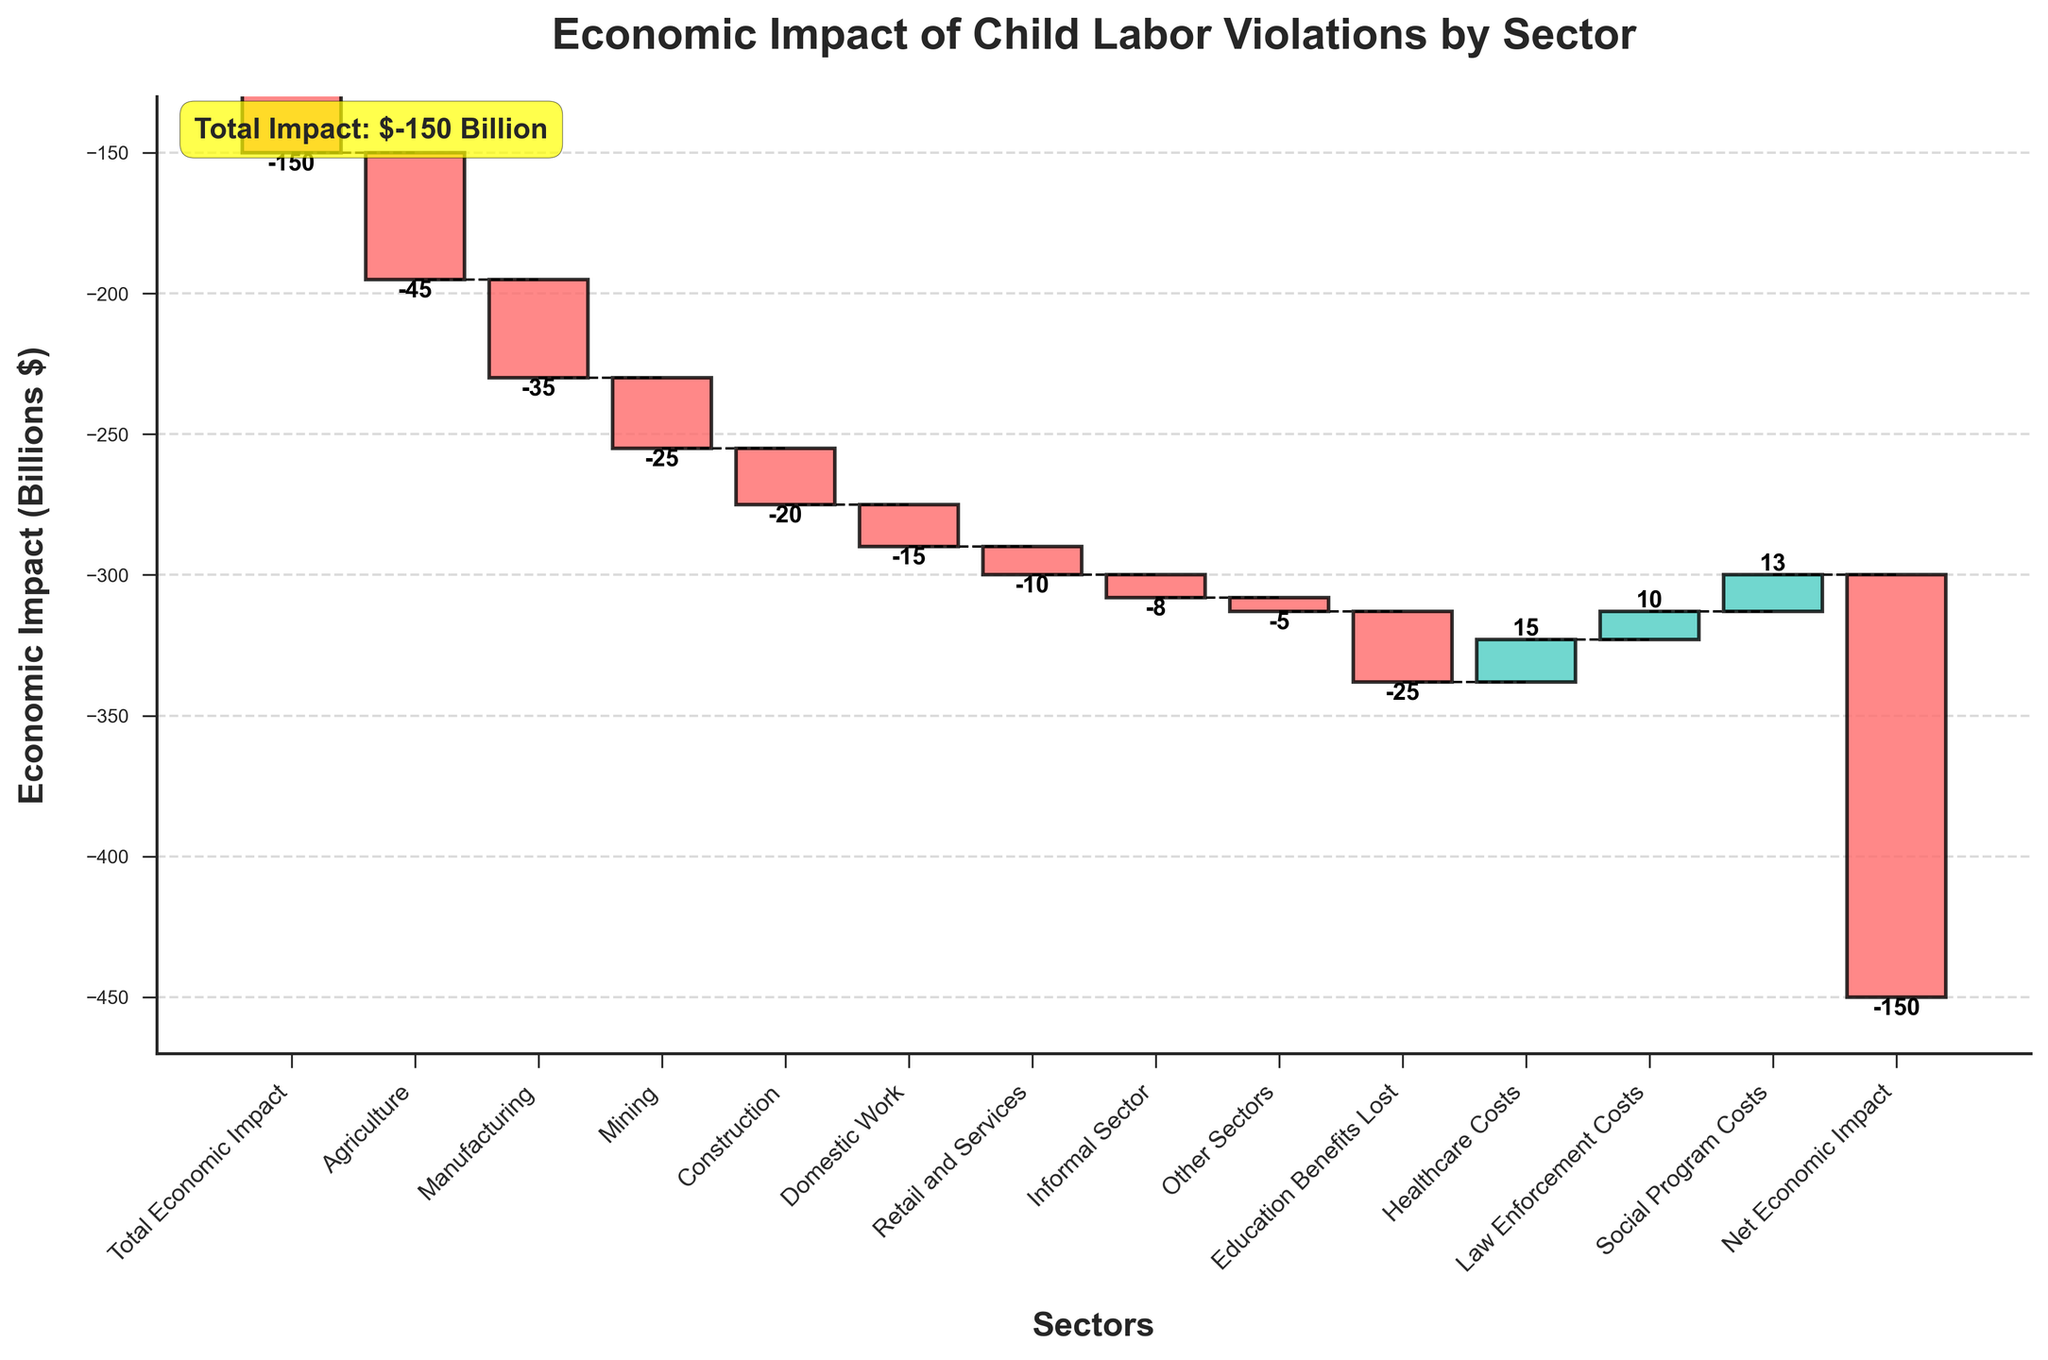What is the title of the chart? The title of the chart is located at the top center and it provides a summary of what the chart is representing. In this case, it's "Economic Impact of Child Labor Violations by Sector".
Answer: Economic Impact of Child Labor Violations by Sector Which sector has the highest negative economic impact? By looking at the height and direction of the bars, the sector represented by the tallest bar going downward will have the highest negative impact. In this case, it is "Agriculture" with a value of -45 billion dollars.
Answer: Agriculture Which three sectors contribute positively to the economic impact? To identify positive contributions, look for bars that extend upward from the baseline. The sectors with positive values are "Healthcare Costs" (15), "Law Enforcement Costs" (10), and "Social Program Costs" (13).
Answer: Healthcare Costs, Law Enforcement Costs, Social Program Costs What is the cumulative economic impact after considering the healthcare costs? Starting with the "Total Economic Impact" of -150 and then adding each subsequent sector's value, the cumulative value after "Healthcare Costs" (which is third from the end) is -180 (-150 + -45 + -35 + ... + 15).
Answer: -167 By how much does the economic impact change due to the "Education Benefits Lost" sector? Find the value associated with "Education Benefits Lost". The economic impact changes by -25 billion dollars, decreasing the cumulative total by this amount.
Answer: -25 billion dollars How does the economic impact of "Mining" compare to "Construction"? Directly compare the values of "Mining" and "Construction". "Mining" contributes -25 billion dollars, whereas "Construction" contributes -20 billion dollars. Consequently, "Mining" has a higher negative impact than "Construction".
Answer: Mining has a higher negative impact What are the total costs from sectors with a negative economic impact in the overall analysis? Sum up only the values from sectors that show a negative impact: -150, -45, -35, -25, -20, -15, -10, -8, -5, -25. The total is -338 billion dollars.
Answer: -338 billion dollars What is the net economic impact displayed on the chart? The net economic impact is explicitly shown as one of the bars and is also noted in the annotation on the chart. Both show it as -150 billion dollars.
Answer: -150 billion dollars How do "Domestic Work" and "Retail and Services" sectors' impacts compare? Compare the values of the two sectors directly. "Domestic Work" impacts by -15 billion dollars, and "Retail and Services" impacts by -10 billion dollars. Therefore, "Domestic Work" has a greater negative impact.
Answer: Domestic Work has a greater negative impact 